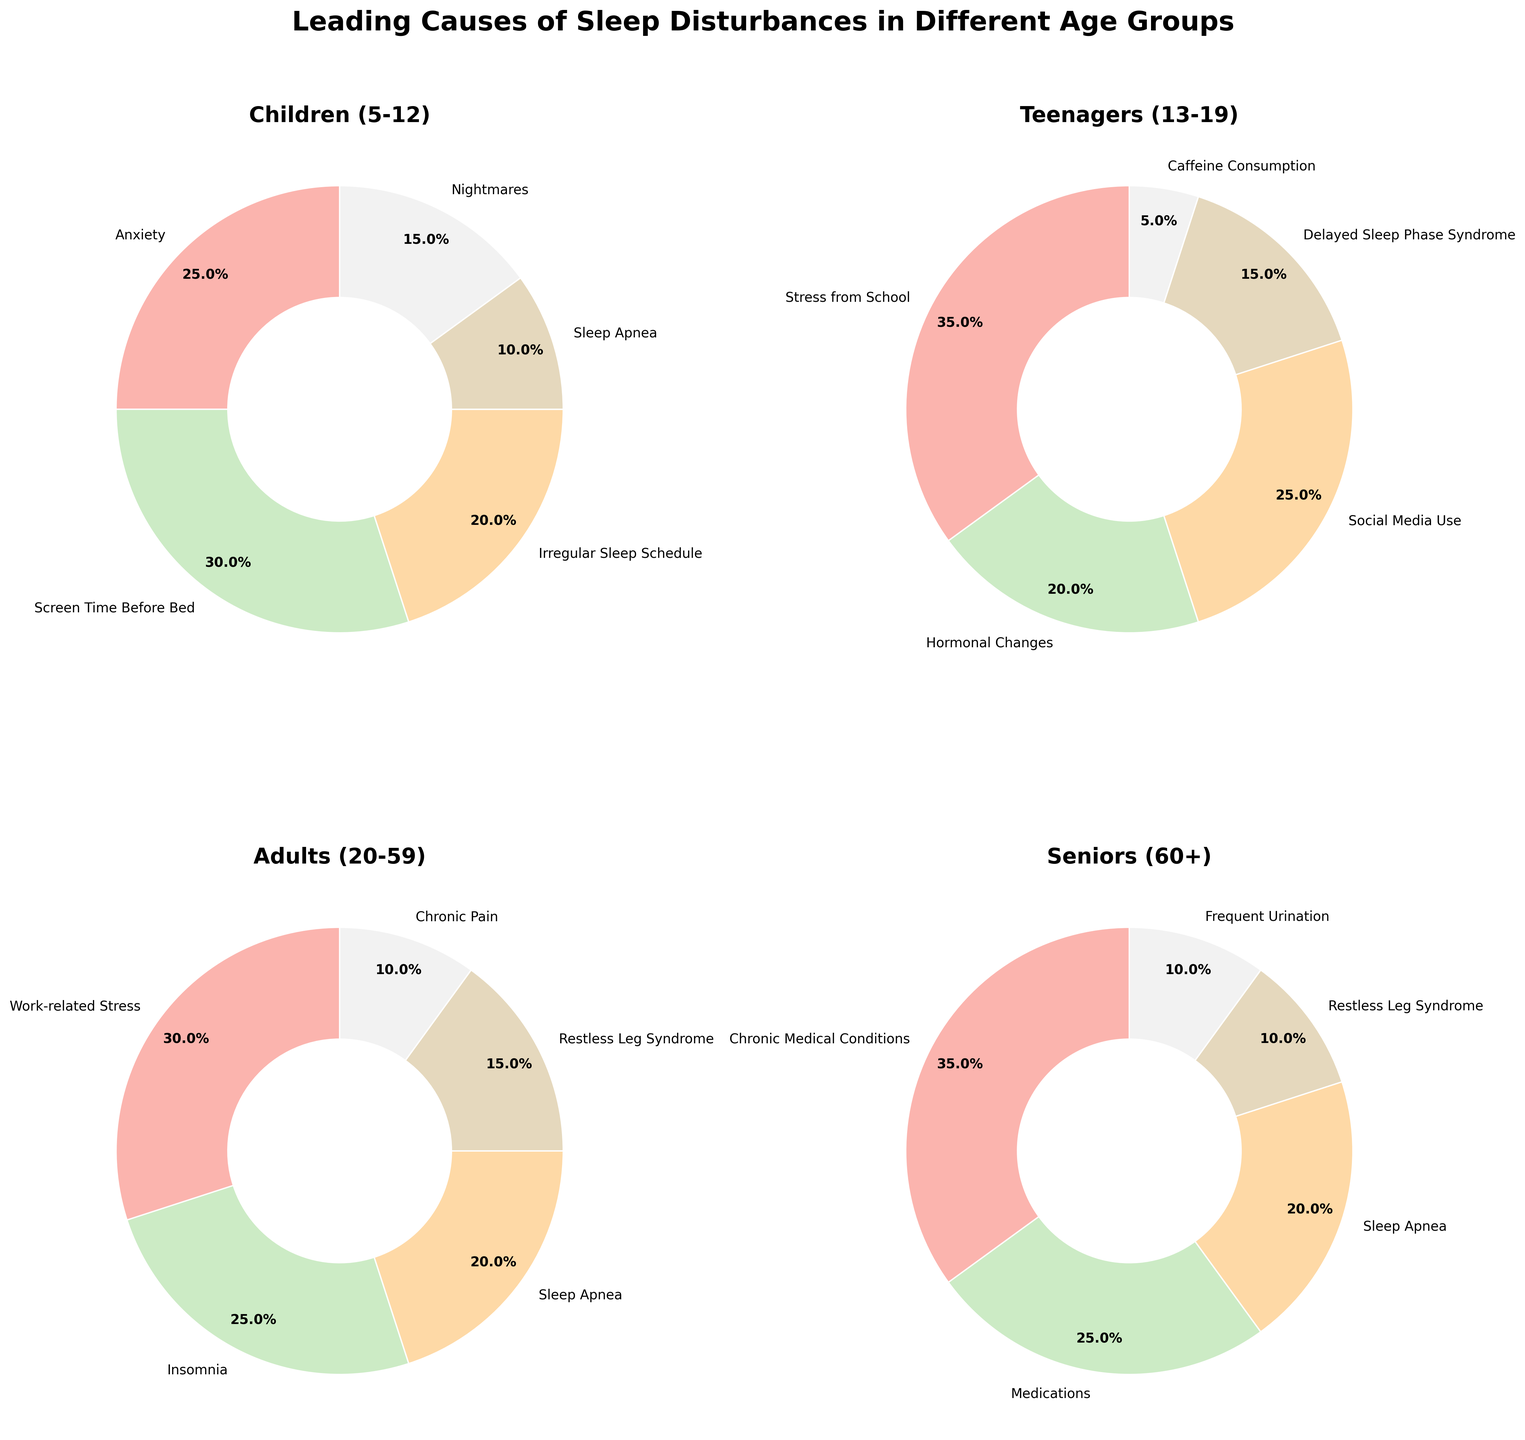Which age group has the highest percentage attributed to a single cause of sleep disturbances? By analyzing the pie charts for each age group, the highest single percentage is seen among seniors (60+) for "Chronic Medical Conditions" at 35%.
Answer: Seniors (60+) What are the two leading causes of sleep disturbances for teenagers (13-19) and their total percentage? From the pie chart for teenagers, the two leading causes are "Stress from School" at 35% and "Social Media Use" at 25%. Their total percentage is 60%.
Answer: 60% Which sleep disturbance cause is common and mentioned across all age groups? By scanning all pie charts, "Sleep Apnea" is the cause appearing in each age group.
Answer: Sleep Apnea Compare the percentage of "Work-related Stress" in adults (20-59) with "Stress from School" in teenagers (13-19). Which is higher and by how much? "Work-related Stress" in adults is 30%, and "Stress from School" in teenagers is 35%. The latter is higher by 5%.
Answer: Stress from School, 5% What is the combined percentage of "Medications" and "Frequent Urination" in seniors (60+)? From the seniors' pie chart, "Medications" is 25% and "Frequent Urination" is 10%. Adding these gives a combined percentage of 35%.
Answer: 35% Which cause of sleep disturbances in children (5-12) has the lowest percentage? The pie chart for children shows "Sleep Apnea" at the lowest percentage, which is 10%.
Answer: Sleep Apnea What is the visual distinction of the cause with the highest percentage within each pie chart? Each pie chart shows the highest percentage cause with a slightly larger slice. For Children (5-12), it's "Screen Time Before Bed"; for Teenagers (13-19), it's "Stress from School"; for Adults (20-59), it's "Work-related Stress"; and for Seniors (60+), it's "Chronic Medical Conditions".
Answer: Different major causes What is the average percentage of "Sleep Apnea" across all age groups? Adding the percentages of "Sleep Apnea" across children (10%), teenagers (15%), adults (20%), and seniors (20%) and dividing by 4 gives an average of 16.25%.
Answer: 16.25% Which age group has the most evenly distributed causes of sleep disturbances? By observing the pie charts, children (5-12) have more evenly distributed percentages across different causes compared to other age groups.
Answer: Children (5-12) 